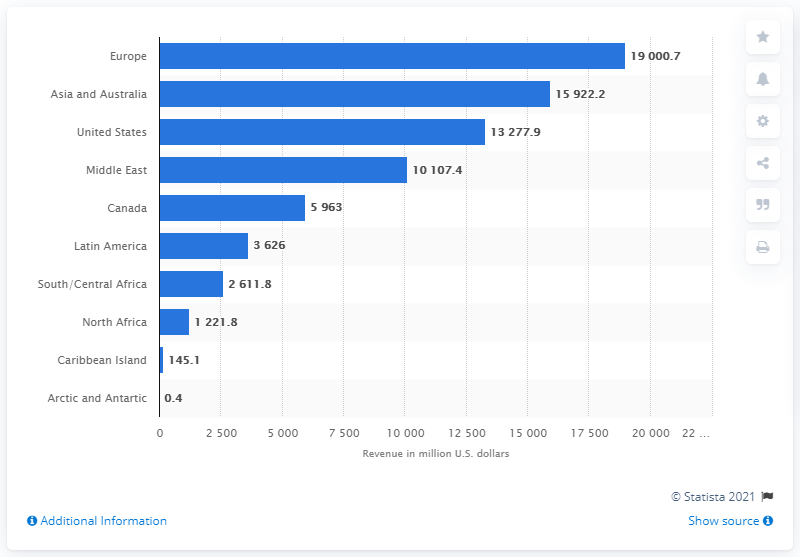Indicate a few pertinent items in this graphic. In 2018, the European construction design industry generated approximately 19,000.7 million euros in revenue. 